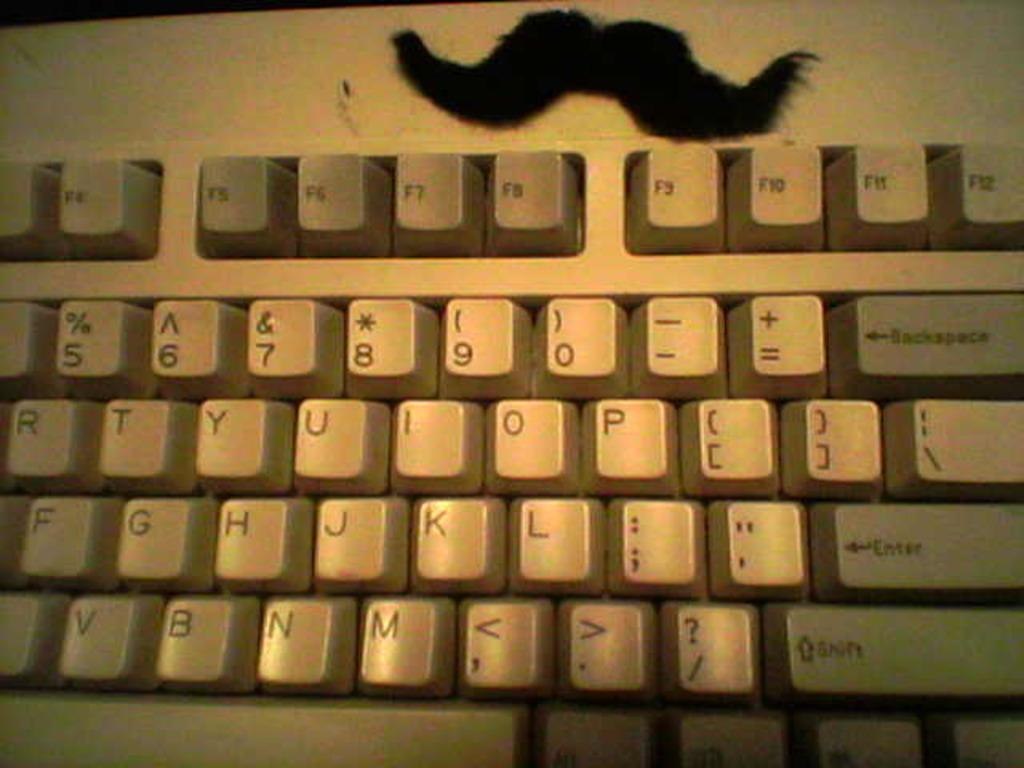<image>
Create a compact narrative representing the image presented. An older model keyboard with a fake mustache. Only letters r through \ , f through enter, and y through shift are shown. 